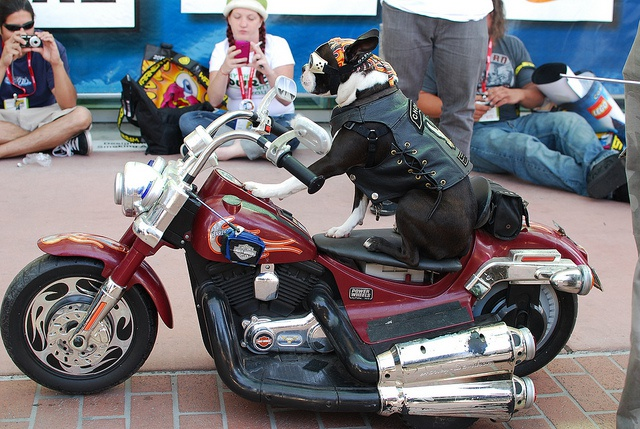Describe the objects in this image and their specific colors. I can see motorcycle in black, darkgray, white, and gray tones, dog in black, gray, lightgray, and darkgray tones, people in black, blue, and gray tones, people in white, black, darkgray, tan, and brown tones, and people in black, gray, and white tones in this image. 